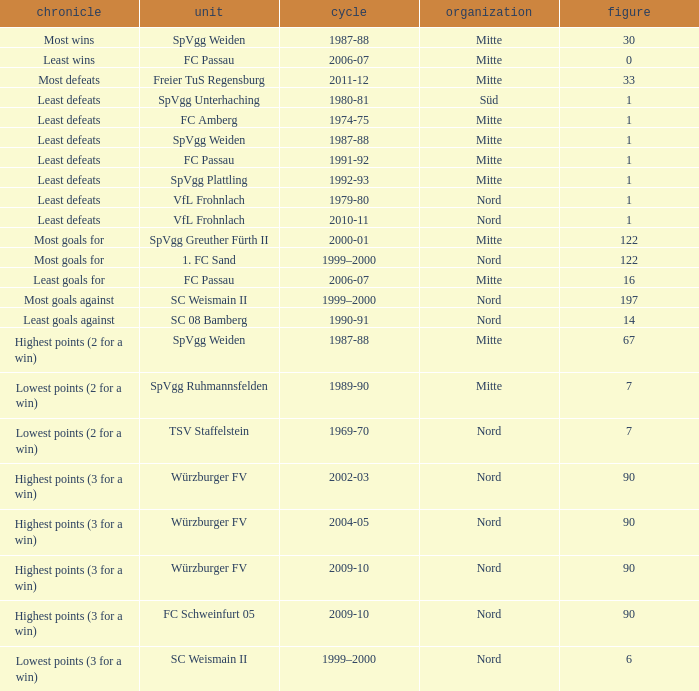What league has most wins as the record? Mitte. 